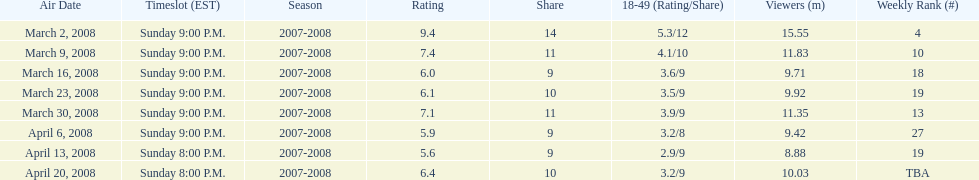How many programs had over 10 million spectators? 4. 